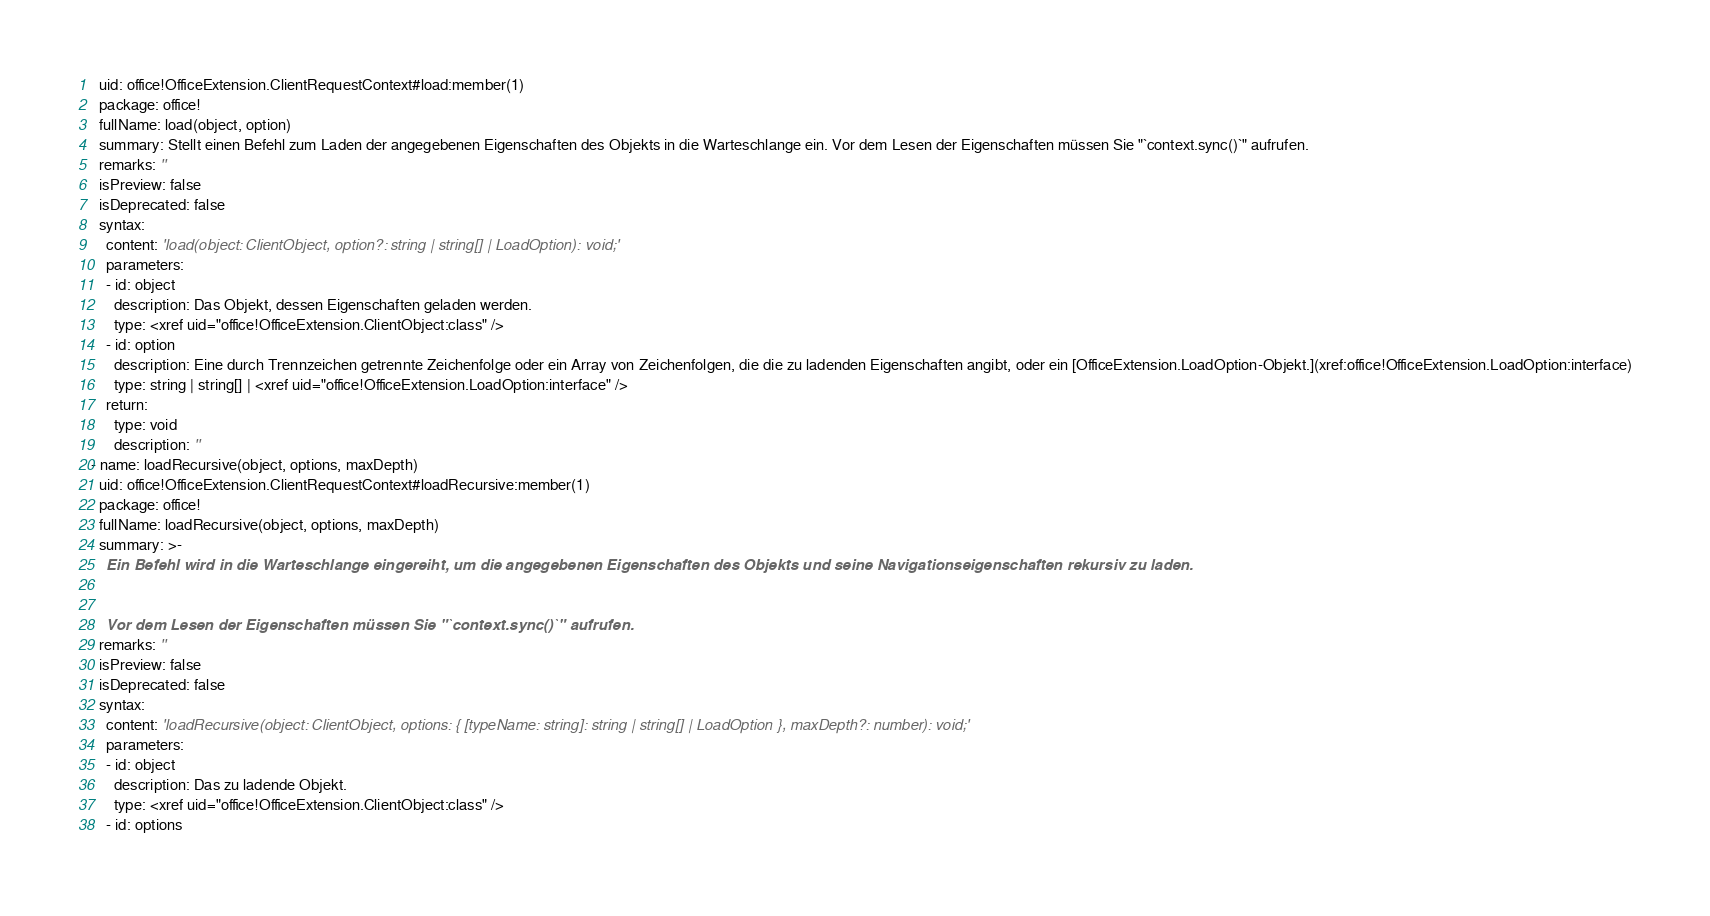Convert code to text. <code><loc_0><loc_0><loc_500><loc_500><_YAML_>  uid: office!OfficeExtension.ClientRequestContext#load:member(1)
  package: office!
  fullName: load(object, option)
  summary: Stellt einen Befehl zum Laden der angegebenen Eigenschaften des Objekts in die Warteschlange ein. Vor dem Lesen der Eigenschaften müssen Sie "`context.sync()`" aufrufen.
  remarks: ''
  isPreview: false
  isDeprecated: false
  syntax:
    content: 'load(object: ClientObject, option?: string | string[] | LoadOption): void;'
    parameters:
    - id: object
      description: Das Objekt, dessen Eigenschaften geladen werden.
      type: <xref uid="office!OfficeExtension.ClientObject:class" />
    - id: option
      description: Eine durch Trennzeichen getrennte Zeichenfolge oder ein Array von Zeichenfolgen, die die zu ladenden Eigenschaften angibt, oder ein [OfficeExtension.LoadOption-Objekt.](xref:office!OfficeExtension.LoadOption:interface)
      type: string | string[] | <xref uid="office!OfficeExtension.LoadOption:interface" />
    return:
      type: void
      description: ''
- name: loadRecursive(object, options, maxDepth)
  uid: office!OfficeExtension.ClientRequestContext#loadRecursive:member(1)
  package: office!
  fullName: loadRecursive(object, options, maxDepth)
  summary: >-
    Ein Befehl wird in die Warteschlange eingereiht, um die angegebenen Eigenschaften des Objekts und seine Navigationseigenschaften rekursiv zu laden.


    Vor dem Lesen der Eigenschaften müssen Sie "`context.sync()`" aufrufen.
  remarks: ''
  isPreview: false
  isDeprecated: false
  syntax:
    content: 'loadRecursive(object: ClientObject, options: { [typeName: string]: string | string[] | LoadOption }, maxDepth?: number): void;'
    parameters:
    - id: object
      description: Das zu ladende Objekt.
      type: <xref uid="office!OfficeExtension.ClientObject:class" />
    - id: options</code> 